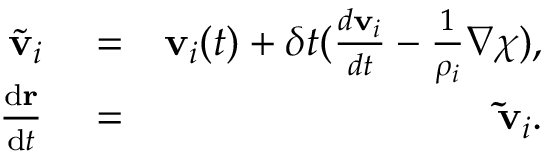<formula> <loc_0><loc_0><loc_500><loc_500>\begin{array} { r l r } { \tilde { v } _ { i } } & = } & { v _ { i } ( t ) + \delta t ( \frac { d v _ { i } } { d t } - \frac { 1 } { \rho _ { i } } \nabla \chi ) , } \\ { \frac { { d } r } { { d } t } } & = } & { \tilde { v } _ { i } . } \end{array}</formula> 